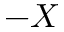<formula> <loc_0><loc_0><loc_500><loc_500>- X</formula> 